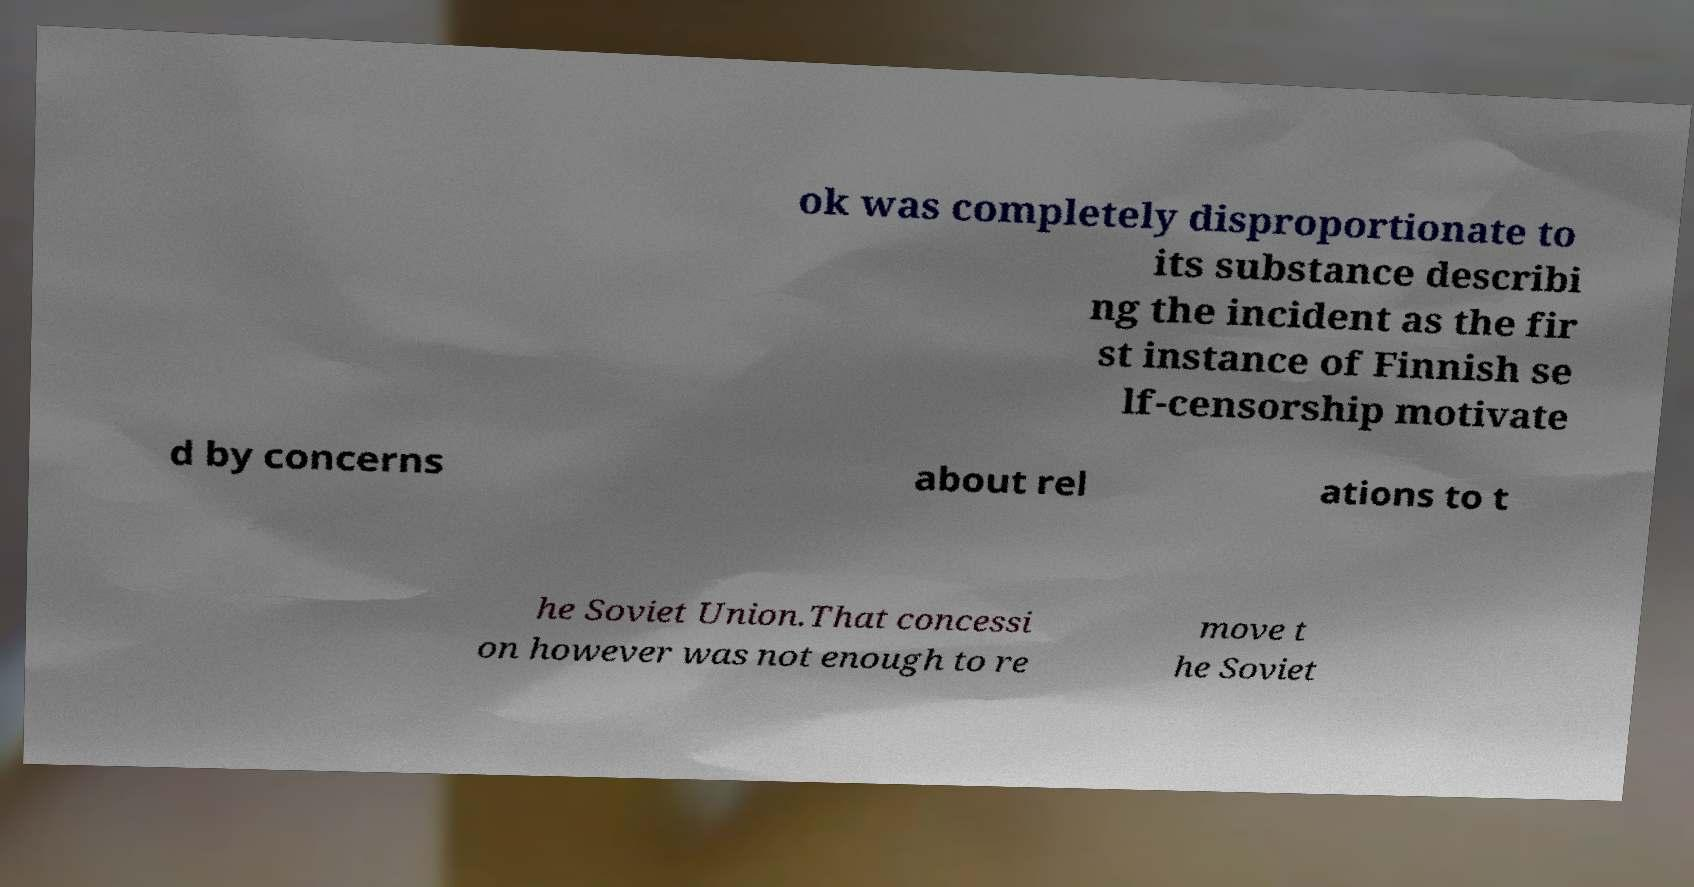Can you read and provide the text displayed in the image?This photo seems to have some interesting text. Can you extract and type it out for me? ok was completely disproportionate to its substance describi ng the incident as the fir st instance of Finnish se lf-censorship motivate d by concerns about rel ations to t he Soviet Union.That concessi on however was not enough to re move t he Soviet 